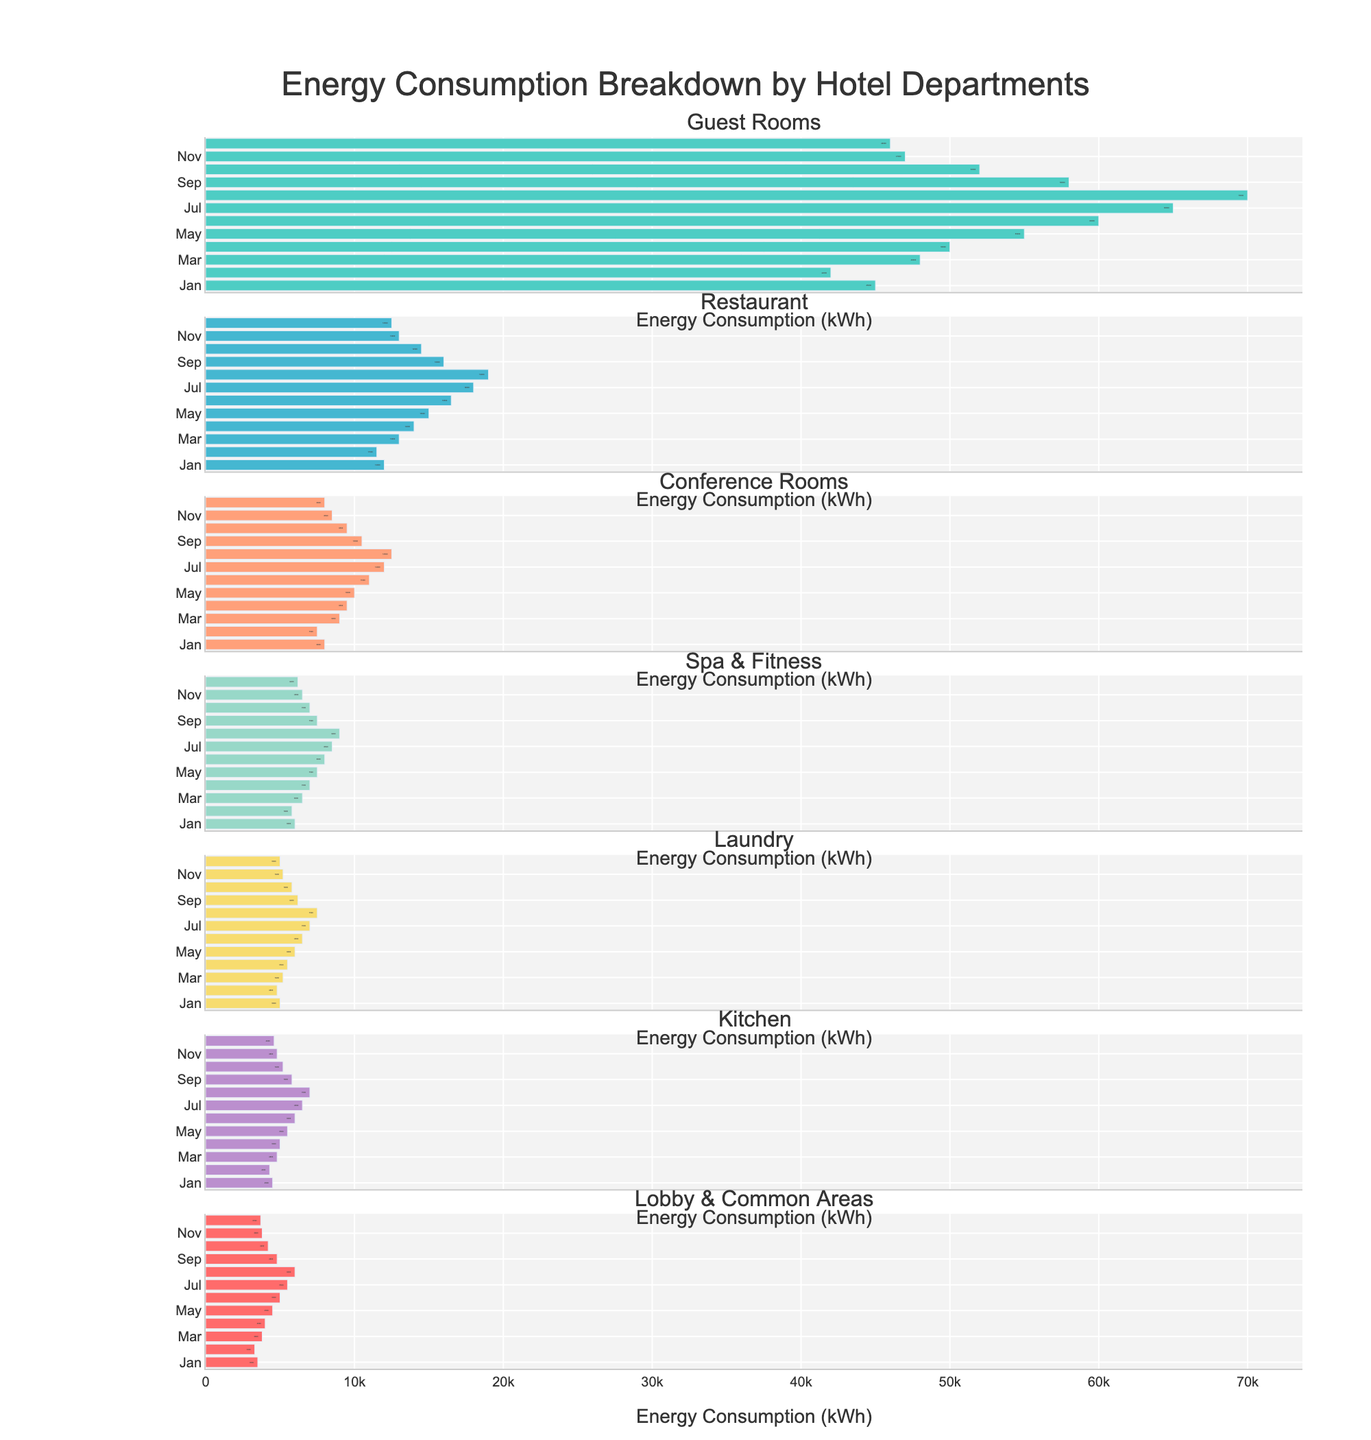what is the title of the figure? The title is located at the top central part of the figure. It is typically larger in font size and set apart from the other text elements.
Answer: Energy Consumption Breakdown by Hotel Departments Which department had the highest energy consumption in July? The bar corresponding to July for each department should be examined. The tallest bar represents the highest consumption. The Guest Rooms department has the tallest bar for July.
Answer: Guest Rooms What is the total energy consumption for the Restaurant department in the first half of the year? Add the values for the Restaurant department from January to June: 12000 + 11500 + 13000 + 14000 + 15000 + 16500 = 82000 kWh.
Answer: 82000 kWh Compare the energy consumption between the Kitchen and Laundry departments in December. Which department consumed more energy? Check the bar corresponding to December for both Kitchen and Laundry. The department with the longer bar consumed more energy. The Kitchen's value is 4600 kWh, while Laundry's value is 5000 kWh.
Answer: Laundry What is the average monthly energy consumption for Spa & Fitness across the entire year? Sum the monthly values of Spa & Fitness and divide by 12. (6000 + 5800 + 6500 + 7000 + 7500 + 8000 + 8500 + 9000 + 7500 + 7000 + 6500 + 6200) / 12 = 7350 kWh.
Answer: 7350 kWh In which month did the Conference Rooms department have the lowest energy consumption? Compare the bars for each month within the Conference Rooms subplot. The shortest bar will indicate the month with the lowest consumption. January has the lowest value of 8000 kWh.
Answer: January During which month did the energy consumption in the Guest Rooms department peak? Identify the month where the bar is the tallest in the Guest Rooms subplot. The month is August with a value of 70000 kWh.
Answer: August What is the combined energy consumption for Lobby & Common Areas and Kitchen in October? Sum the energy values for Lobby & Common Areas and Kitchen departments in October: 4200 + 5200 = 9400 kWh.
Answer: 9400 kWh Which department had more consistent energy consumption throughout the year, the Restaurant or Laundry? Analyze the variation in bar lengths for each month. If the bars are more similar in length, it indicates consistency. The Laundry department shows more consistent bars throughout the year compared to the Restaurant, which has more visible fluctuations.
Answer: Laundry How much more energy did Spa & Fitness consume in August compared to January? Subtract the energy value in January from August for the Spa & Fitness department: 9000 - 6000 = 3000 kWh.
Answer: 3000 kWh 